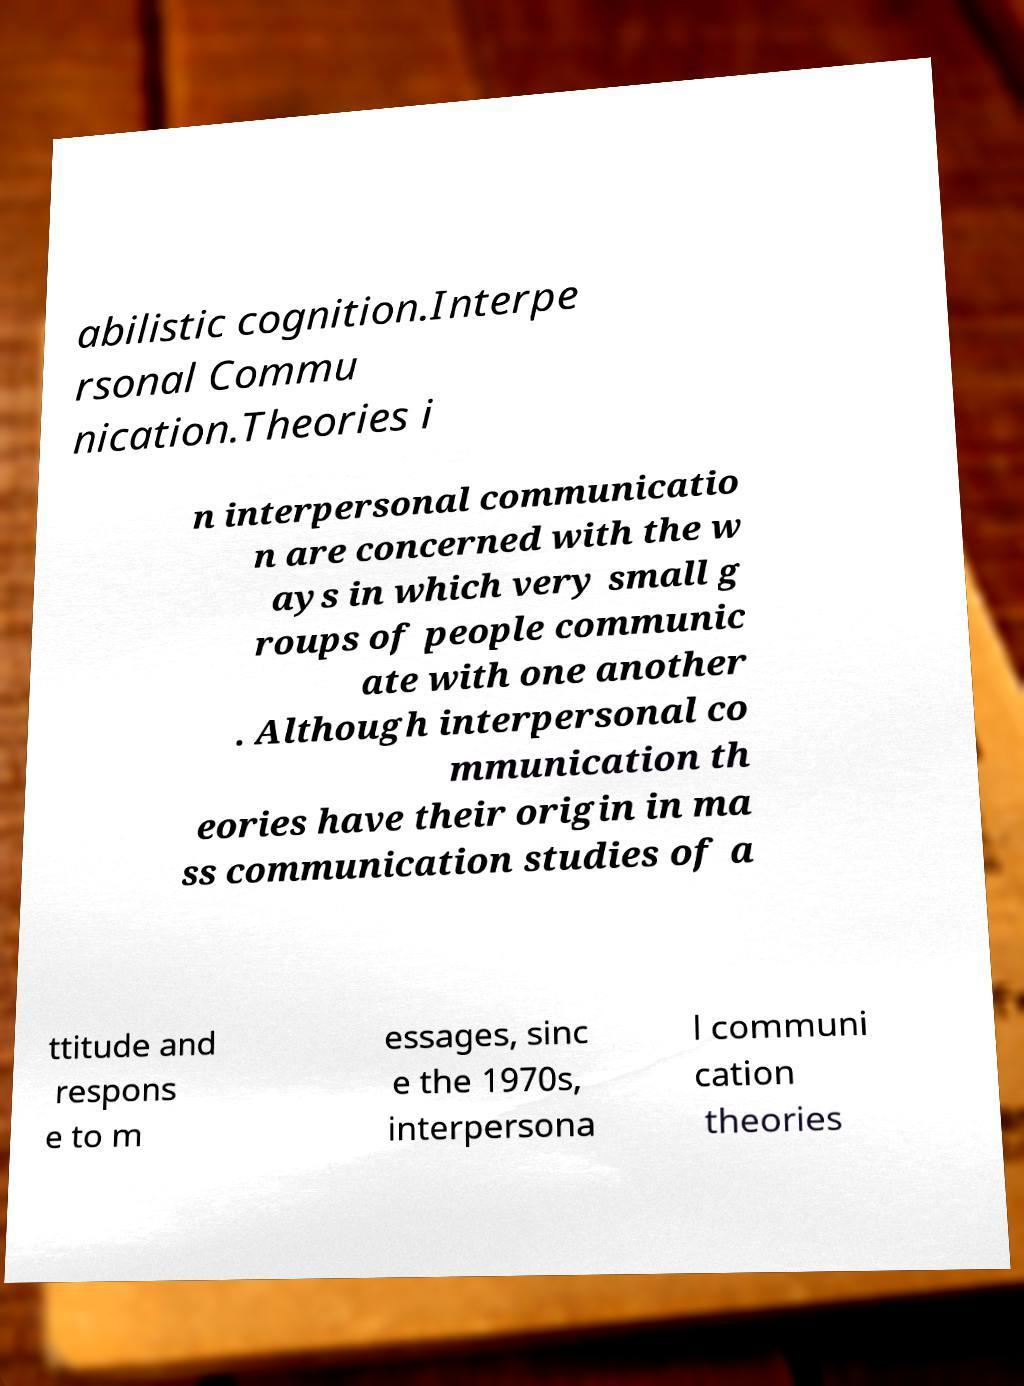Could you extract and type out the text from this image? abilistic cognition.Interpe rsonal Commu nication.Theories i n interpersonal communicatio n are concerned with the w ays in which very small g roups of people communic ate with one another . Although interpersonal co mmunication th eories have their origin in ma ss communication studies of a ttitude and respons e to m essages, sinc e the 1970s, interpersona l communi cation theories 